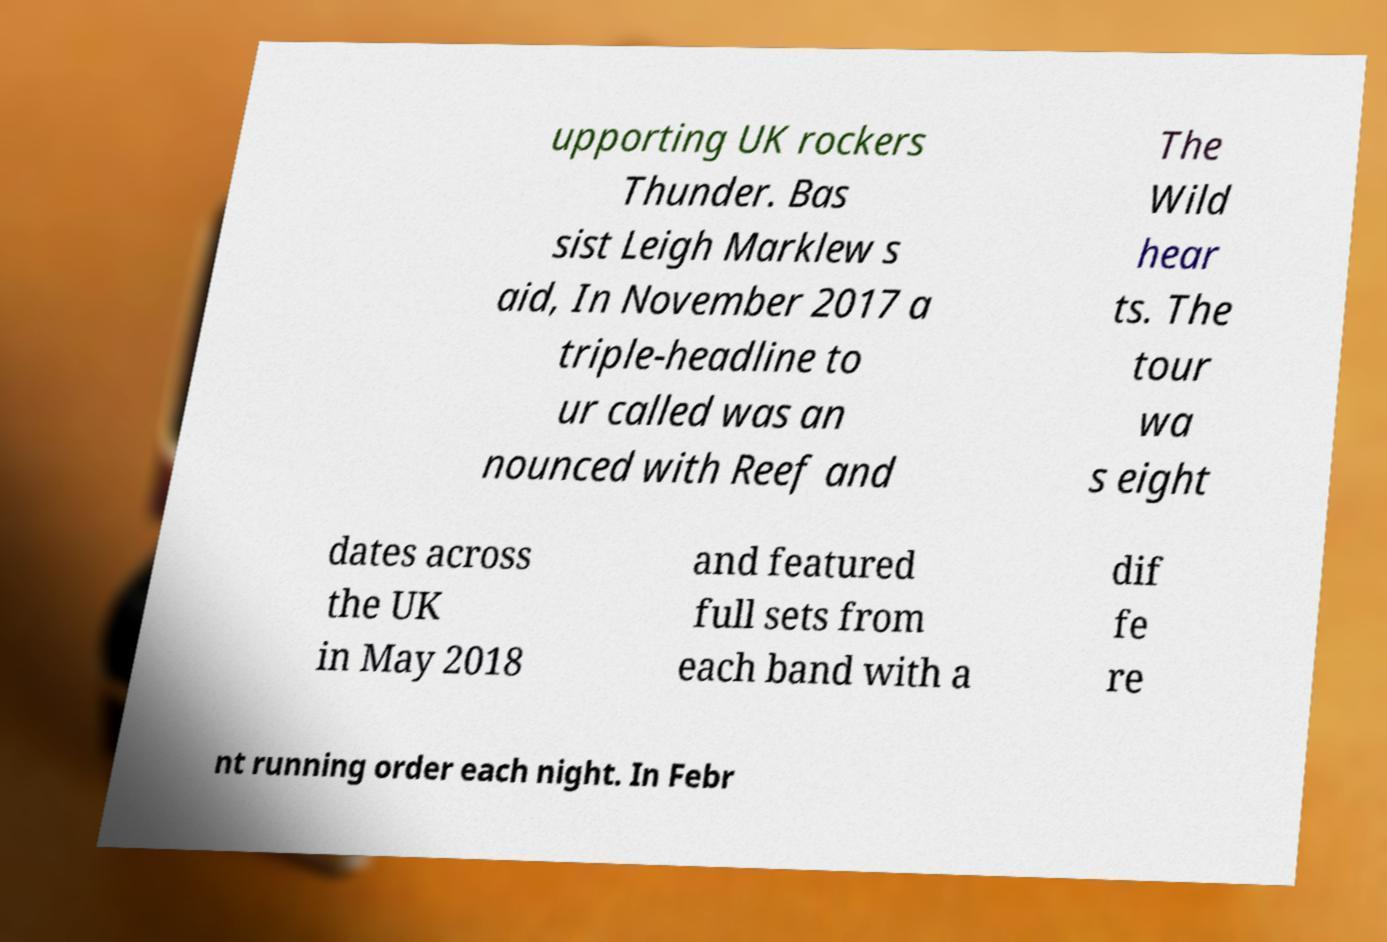For documentation purposes, I need the text within this image transcribed. Could you provide that? upporting UK rockers Thunder. Bas sist Leigh Marklew s aid, In November 2017 a triple-headline to ur called was an nounced with Reef and The Wild hear ts. The tour wa s eight dates across the UK in May 2018 and featured full sets from each band with a dif fe re nt running order each night. In Febr 